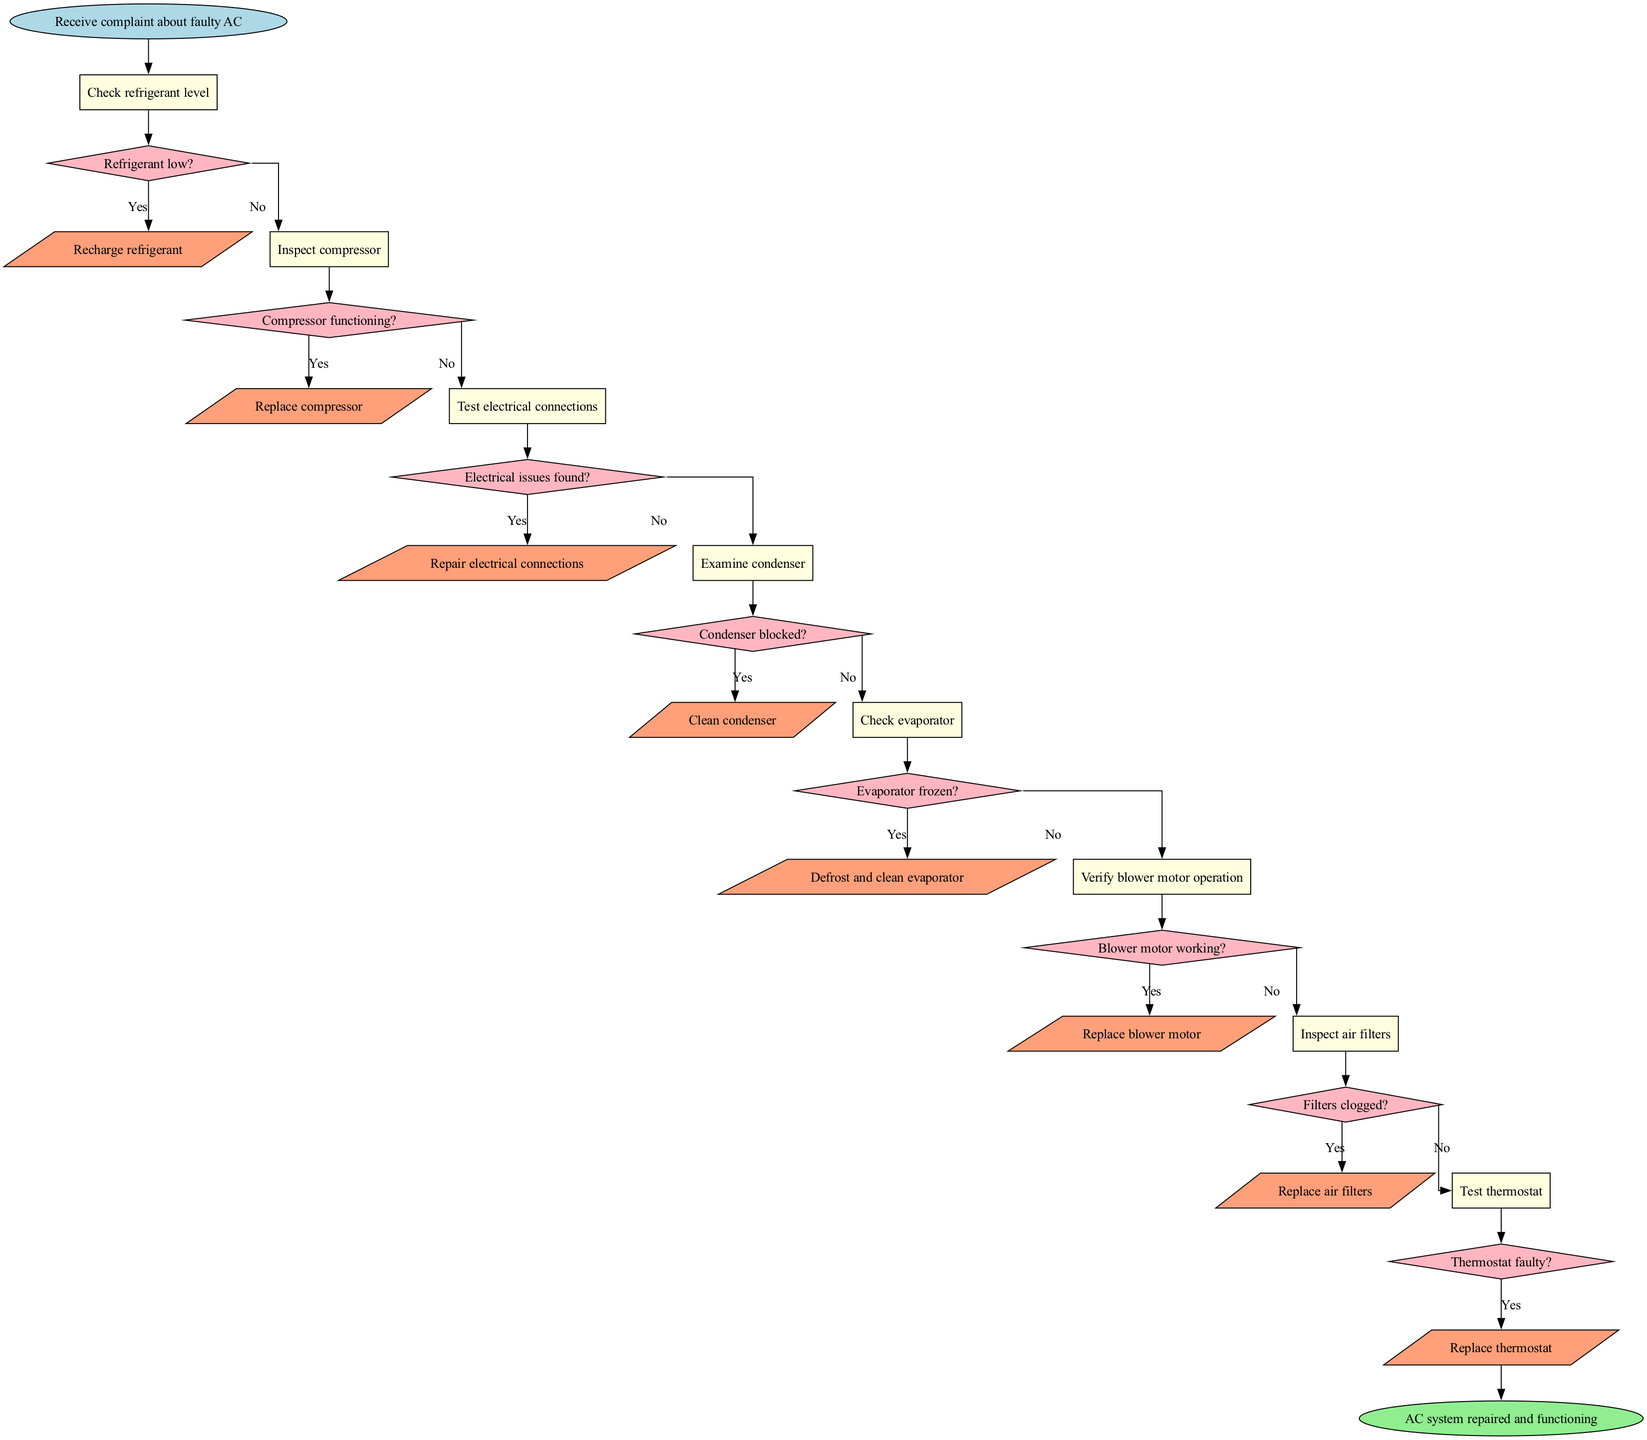What is the first step in troubleshooting the AC system? The flowchart starts with receiving a complaint about a faulty AC system, which is the first step in the process.
Answer: Receive complaint about faulty AC What is the last action performed before finishing the flowchart? The last action taken in the flowchart is to reach the end node, which signifies that the AC system is repaired and functioning. This is confirmed by the pathway leading from the last action node to the end node.
Answer: AC system repaired and functioning How many decision nodes are there in the flowchart? The flowchart contains a total of 8 decision nodes that ask about various conditions related to the AC system's components. By counting the decision nodes listed, we find the total number.
Answer: 8 What action is taken if the refrigerant level is low? If the refrigerant level is found to be low, the action specified in the flowchart is to recharge the refrigerant, indicated by the connection from the decision node for refrigerant level to its corresponding action node.
Answer: Recharge refrigerant What question is asked after inspecting the compressor? The question posed after inspecting the compressor is whether the compressor is functioning, as this follows the inspection step in the flowchart.
Answer: Compressor functioning? What happens if electrical issues are found? If electrical issues are found according to the flowchart, the corresponding action is to repair the electrical connections, which follows the decision point regarding electrical issues.
Answer: Repair electrical connections Which component is checked after examining the condenser? After examining the condenser, the next component checked is the evaporator, as indicated by the sequential flow of the diagram that directs from the condenser to the evaporator check.
Answer: Check evaporator What should be done if the blower motor is not working? If the blower motor is found to be not working, the action specified in the flowchart is to replace the blower motor, shown in the pathway from the blower motor decision node to its action node.
Answer: Replace blower motor 